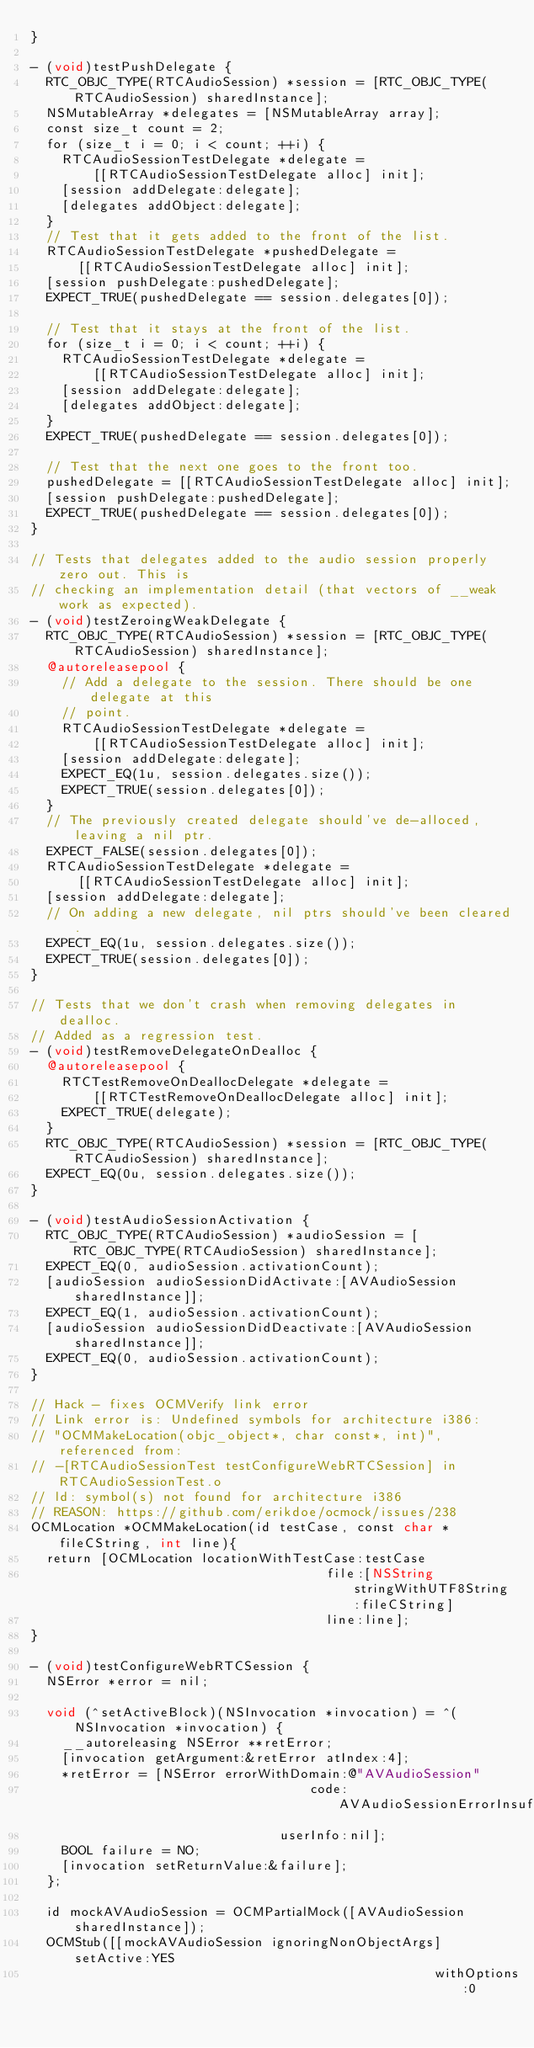Convert code to text. <code><loc_0><loc_0><loc_500><loc_500><_ObjectiveC_>}

- (void)testPushDelegate {
  RTC_OBJC_TYPE(RTCAudioSession) *session = [RTC_OBJC_TYPE(RTCAudioSession) sharedInstance];
  NSMutableArray *delegates = [NSMutableArray array];
  const size_t count = 2;
  for (size_t i = 0; i < count; ++i) {
    RTCAudioSessionTestDelegate *delegate =
        [[RTCAudioSessionTestDelegate alloc] init];
    [session addDelegate:delegate];
    [delegates addObject:delegate];
  }
  // Test that it gets added to the front of the list.
  RTCAudioSessionTestDelegate *pushedDelegate =
      [[RTCAudioSessionTestDelegate alloc] init];
  [session pushDelegate:pushedDelegate];
  EXPECT_TRUE(pushedDelegate == session.delegates[0]);

  // Test that it stays at the front of the list.
  for (size_t i = 0; i < count; ++i) {
    RTCAudioSessionTestDelegate *delegate =
        [[RTCAudioSessionTestDelegate alloc] init];
    [session addDelegate:delegate];
    [delegates addObject:delegate];
  }
  EXPECT_TRUE(pushedDelegate == session.delegates[0]);

  // Test that the next one goes to the front too.
  pushedDelegate = [[RTCAudioSessionTestDelegate alloc] init];
  [session pushDelegate:pushedDelegate];
  EXPECT_TRUE(pushedDelegate == session.delegates[0]);
}

// Tests that delegates added to the audio session properly zero out. This is
// checking an implementation detail (that vectors of __weak work as expected).
- (void)testZeroingWeakDelegate {
  RTC_OBJC_TYPE(RTCAudioSession) *session = [RTC_OBJC_TYPE(RTCAudioSession) sharedInstance];
  @autoreleasepool {
    // Add a delegate to the session. There should be one delegate at this
    // point.
    RTCAudioSessionTestDelegate *delegate =
        [[RTCAudioSessionTestDelegate alloc] init];
    [session addDelegate:delegate];
    EXPECT_EQ(1u, session.delegates.size());
    EXPECT_TRUE(session.delegates[0]);
  }
  // The previously created delegate should've de-alloced, leaving a nil ptr.
  EXPECT_FALSE(session.delegates[0]);
  RTCAudioSessionTestDelegate *delegate =
      [[RTCAudioSessionTestDelegate alloc] init];
  [session addDelegate:delegate];
  // On adding a new delegate, nil ptrs should've been cleared.
  EXPECT_EQ(1u, session.delegates.size());
  EXPECT_TRUE(session.delegates[0]);
}

// Tests that we don't crash when removing delegates in dealloc.
// Added as a regression test.
- (void)testRemoveDelegateOnDealloc {
  @autoreleasepool {
    RTCTestRemoveOnDeallocDelegate *delegate =
        [[RTCTestRemoveOnDeallocDelegate alloc] init];
    EXPECT_TRUE(delegate);
  }
  RTC_OBJC_TYPE(RTCAudioSession) *session = [RTC_OBJC_TYPE(RTCAudioSession) sharedInstance];
  EXPECT_EQ(0u, session.delegates.size());
}

- (void)testAudioSessionActivation {
  RTC_OBJC_TYPE(RTCAudioSession) *audioSession = [RTC_OBJC_TYPE(RTCAudioSession) sharedInstance];
  EXPECT_EQ(0, audioSession.activationCount);
  [audioSession audioSessionDidActivate:[AVAudioSession sharedInstance]];
  EXPECT_EQ(1, audioSession.activationCount);
  [audioSession audioSessionDidDeactivate:[AVAudioSession sharedInstance]];
  EXPECT_EQ(0, audioSession.activationCount);
}

// Hack - fixes OCMVerify link error
// Link error is: Undefined symbols for architecture i386:
// "OCMMakeLocation(objc_object*, char const*, int)", referenced from:
// -[RTCAudioSessionTest testConfigureWebRTCSession] in RTCAudioSessionTest.o
// ld: symbol(s) not found for architecture i386
// REASON: https://github.com/erikdoe/ocmock/issues/238
OCMLocation *OCMMakeLocation(id testCase, const char *fileCString, int line){
  return [OCMLocation locationWithTestCase:testCase
                                      file:[NSString stringWithUTF8String:fileCString]
                                      line:line];
}

- (void)testConfigureWebRTCSession {
  NSError *error = nil;

  void (^setActiveBlock)(NSInvocation *invocation) = ^(NSInvocation *invocation) {
    __autoreleasing NSError **retError;
    [invocation getArgument:&retError atIndex:4];
    *retError = [NSError errorWithDomain:@"AVAudioSession"
                                    code:AVAudioSessionErrorInsufficientPriority
                                userInfo:nil];
    BOOL failure = NO;
    [invocation setReturnValue:&failure];
  };

  id mockAVAudioSession = OCMPartialMock([AVAudioSession sharedInstance]);
  OCMStub([[mockAVAudioSession ignoringNonObjectArgs] setActive:YES
                                                    withOptions:0</code> 